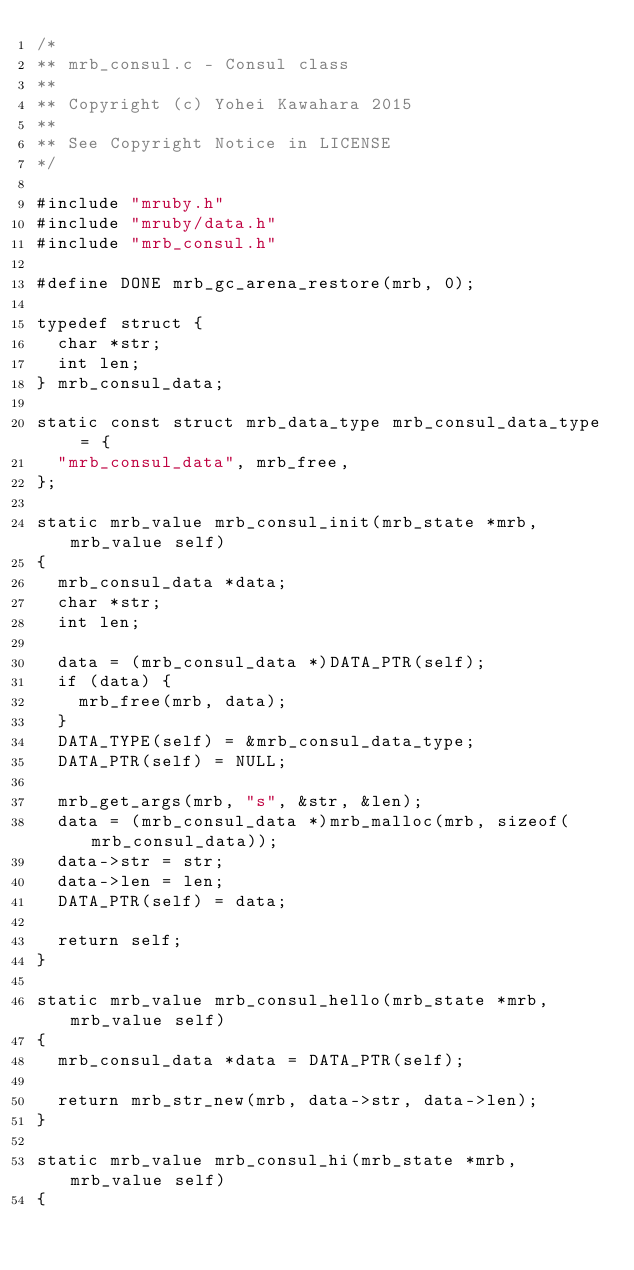Convert code to text. <code><loc_0><loc_0><loc_500><loc_500><_C_>/*
** mrb_consul.c - Consul class
**
** Copyright (c) Yohei Kawahara 2015
**
** See Copyright Notice in LICENSE
*/

#include "mruby.h"
#include "mruby/data.h"
#include "mrb_consul.h"

#define DONE mrb_gc_arena_restore(mrb, 0);

typedef struct {
  char *str;
  int len;
} mrb_consul_data;

static const struct mrb_data_type mrb_consul_data_type = {
  "mrb_consul_data", mrb_free,
};

static mrb_value mrb_consul_init(mrb_state *mrb, mrb_value self)
{
  mrb_consul_data *data;
  char *str;
  int len;

  data = (mrb_consul_data *)DATA_PTR(self);
  if (data) {
    mrb_free(mrb, data);
  }
  DATA_TYPE(self) = &mrb_consul_data_type;
  DATA_PTR(self) = NULL;

  mrb_get_args(mrb, "s", &str, &len);
  data = (mrb_consul_data *)mrb_malloc(mrb, sizeof(mrb_consul_data));
  data->str = str;
  data->len = len;
  DATA_PTR(self) = data;

  return self;
}

static mrb_value mrb_consul_hello(mrb_state *mrb, mrb_value self)
{
  mrb_consul_data *data = DATA_PTR(self);

  return mrb_str_new(mrb, data->str, data->len);
}

static mrb_value mrb_consul_hi(mrb_state *mrb, mrb_value self)
{</code> 